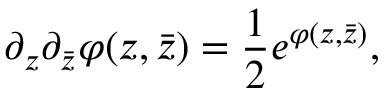Convert formula to latex. <formula><loc_0><loc_0><loc_500><loc_500>\partial _ { z } \partial _ { \bar { z } } \varphi ( z , \bar { z } ) = { \frac { 1 } { 2 } } e ^ { \varphi ( z , \bar { z } ) } ,</formula> 